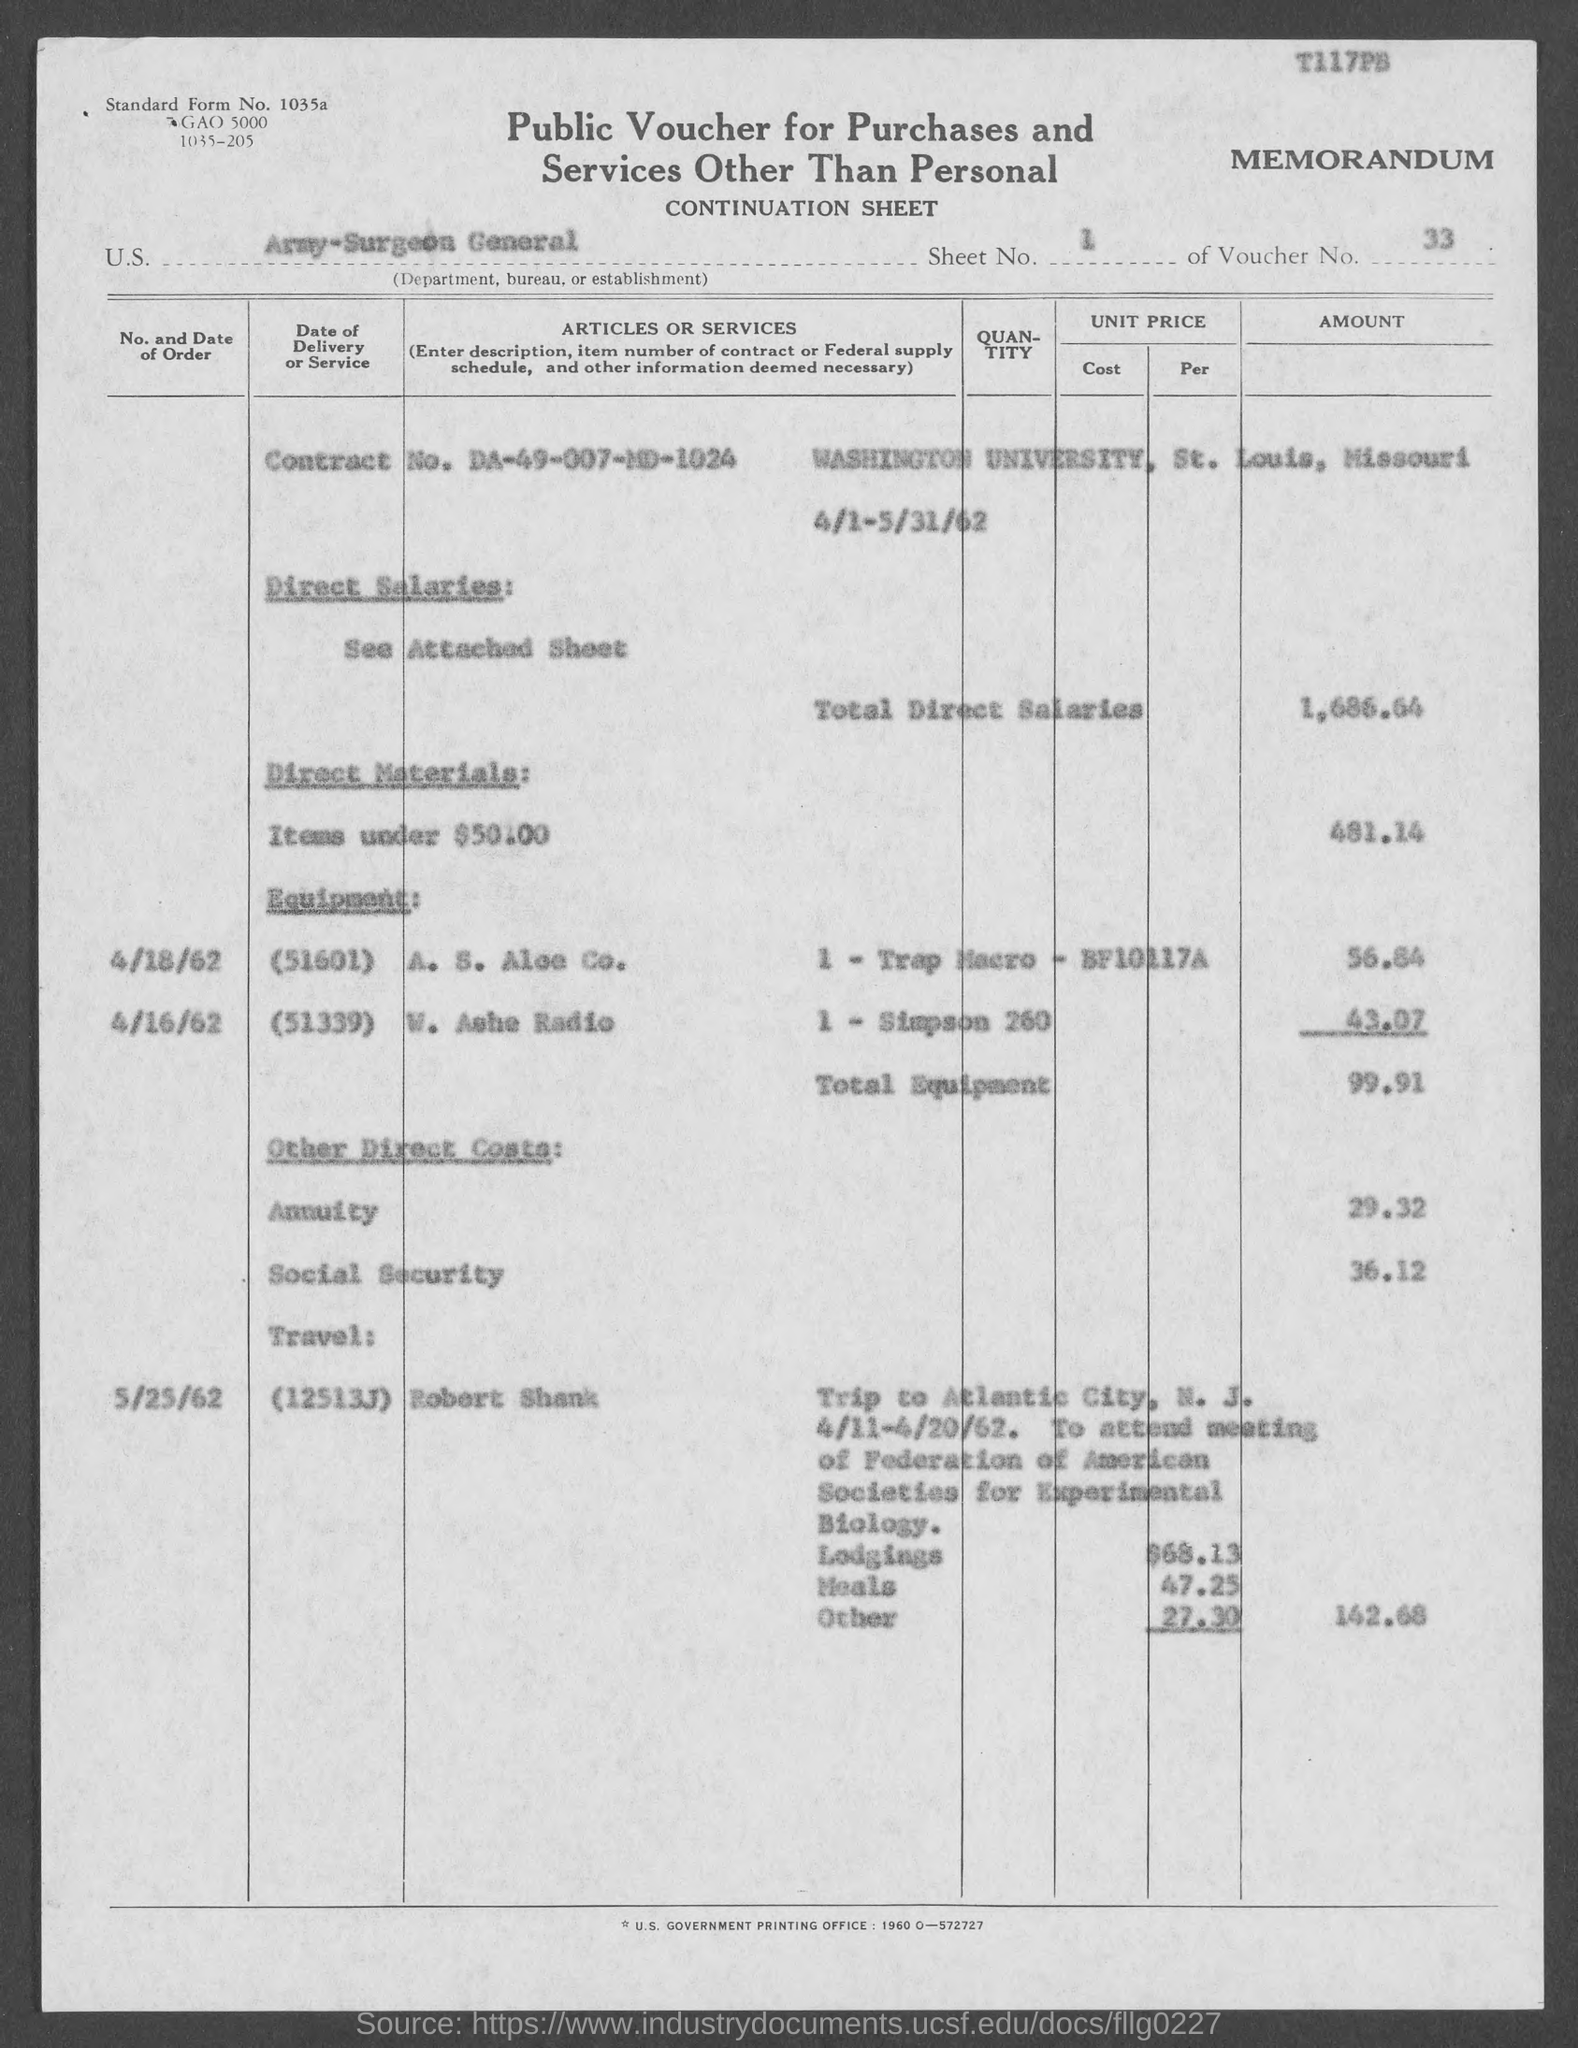What is the document title?
Your answer should be compact. Public Voucher for Purchases and Services Other Than Personal. What is the sheet no.?
Your answer should be compact. 1. What is the voucher number?
Keep it short and to the point. 33. What is the Contract No.?
Your answer should be compact. DA-49-007-MD-1024. What is the total direct salaries in $?
Make the answer very short. 1,686.64. 